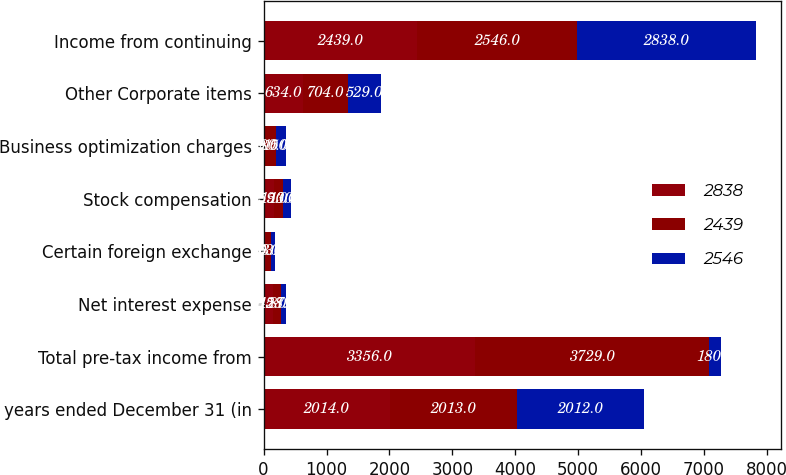<chart> <loc_0><loc_0><loc_500><loc_500><stacked_bar_chart><ecel><fcel>years ended December 31 (in<fcel>Total pre-tax income from<fcel>Net interest expense<fcel>Certain foreign exchange<fcel>Stock compensation<fcel>Business optimization charges<fcel>Other Corporate items<fcel>Income from continuing<nl><fcel>2838<fcel>2014<fcel>3356<fcel>145<fcel>40<fcel>159<fcel>19<fcel>634<fcel>2439<nl><fcel>2439<fcel>2013<fcel>3729<fcel>128<fcel>83<fcel>150<fcel>180<fcel>704<fcel>2546<nl><fcel>2546<fcel>2012<fcel>180<fcel>87<fcel>53<fcel>130<fcel>150<fcel>529<fcel>2838<nl></chart> 